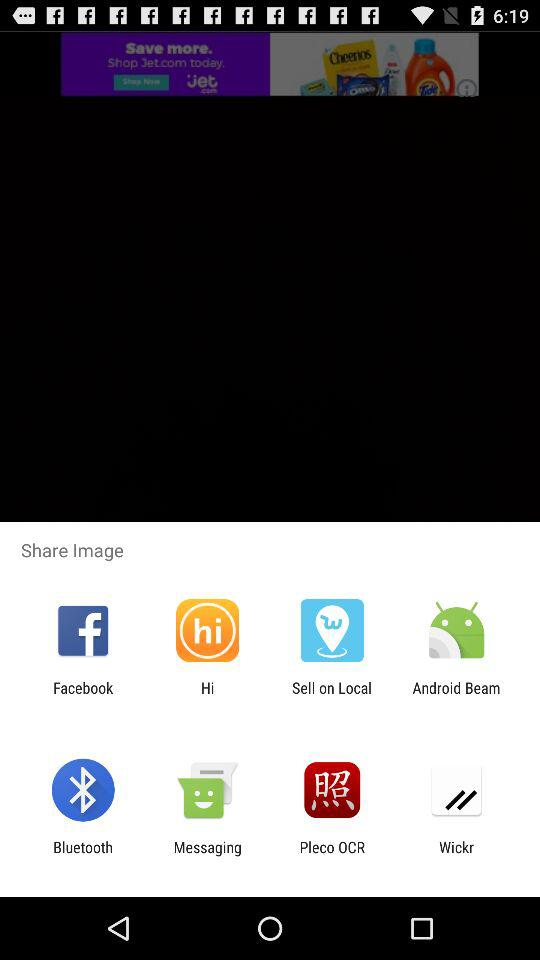What are the different sharing options? The options are "Facebook", "Hi", "Sell on Local", "Android Beam", "Bluetooth", "Messaging", "Pleco OCR", and "Wickr". 